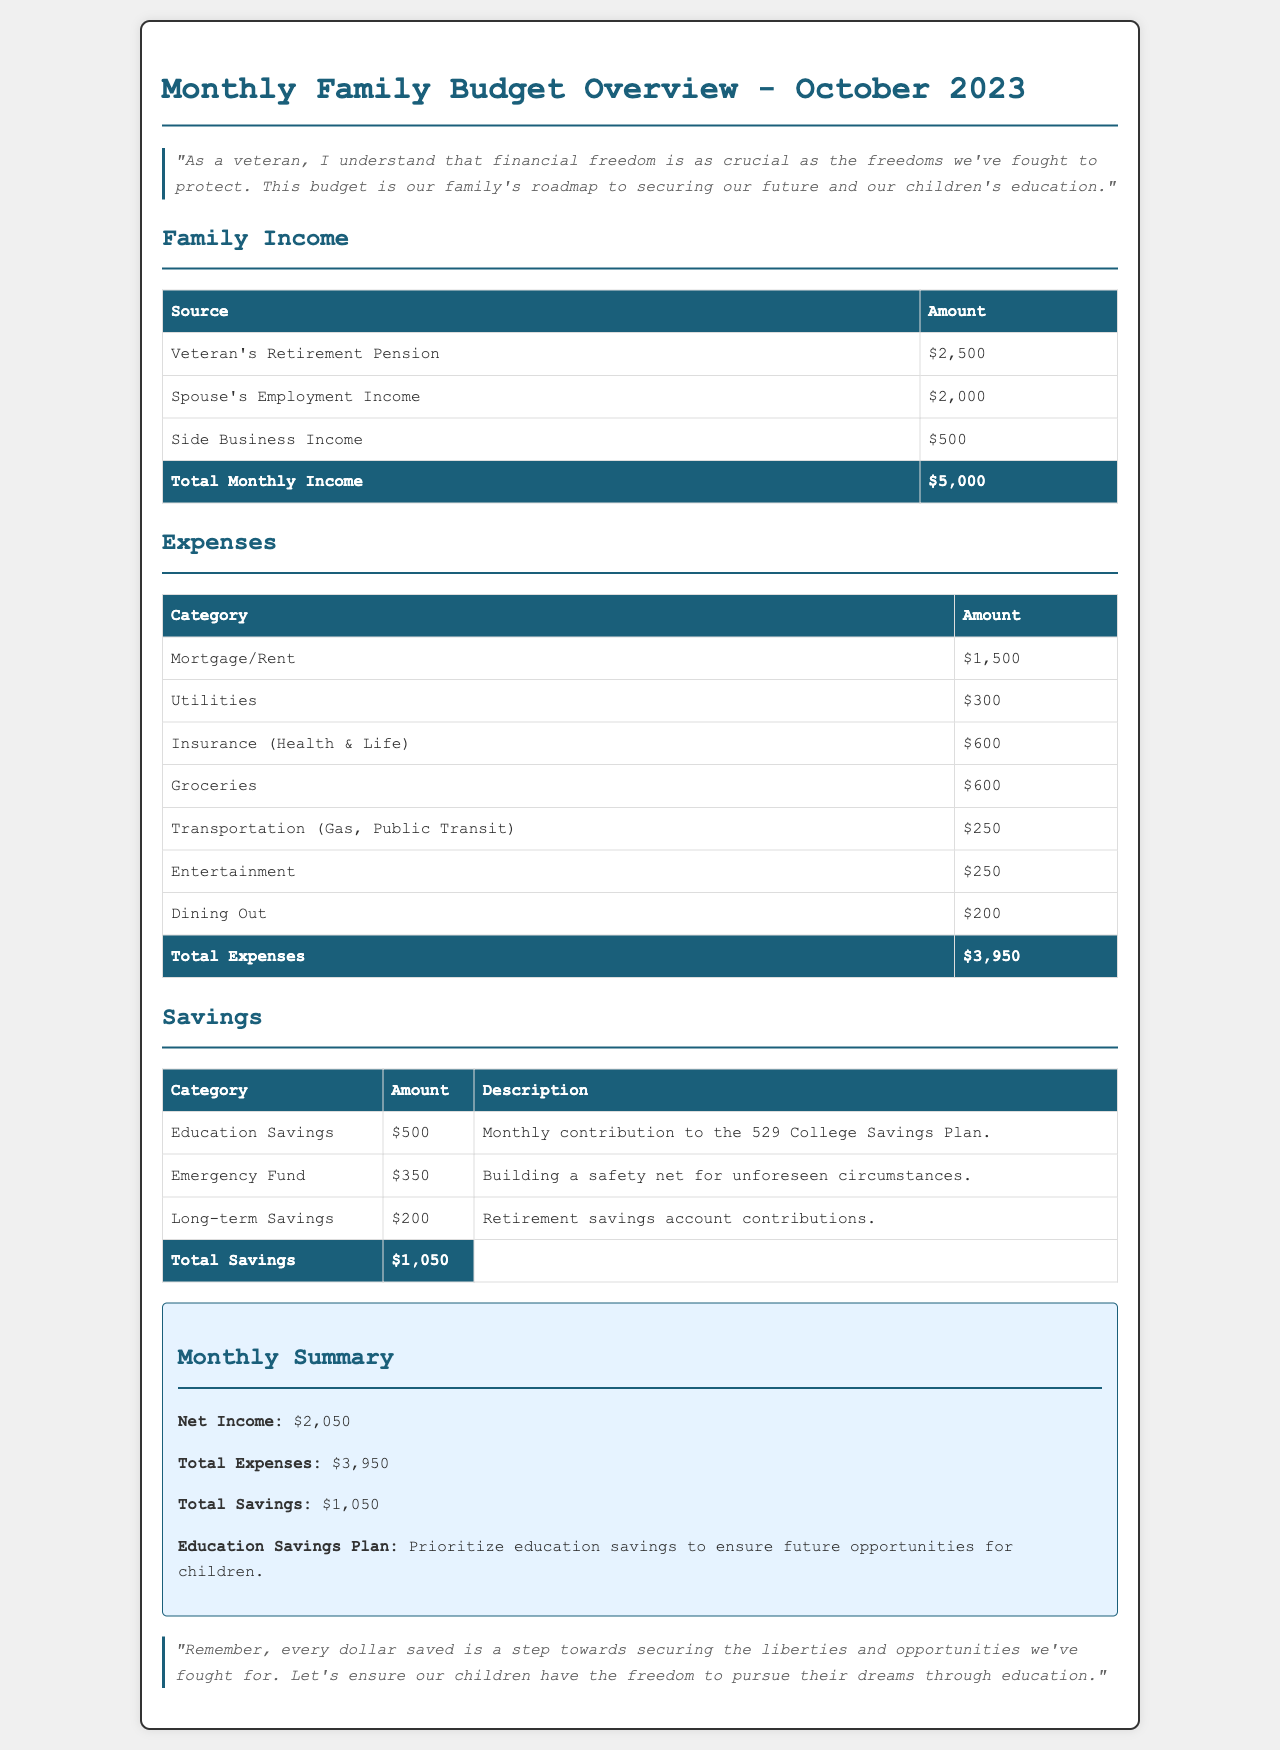What is the total monthly income? The total monthly income is the sum of all income sources listed in the document: $2,500 + $2,000 + $500 = $5,000.
Answer: $5,000 What is the category with the highest expense? The highest individual expense is the Mortgage/Rent at $1,500.
Answer: Mortgage/Rent How much is allocated for education savings? The document specifies a monthly contribution of $500 for Education Savings.
Answer: $500 What is the net income for the month? Net income is calculated by subtracting total expenses from total income: $5,000 - $3,950 = $2,050.
Answer: $2,050 What is the total amount spent on utilities? The total expense under the Utilities category is stated in the document as $300.
Answer: $300 How much is saved in the Emergency Fund? The Emergency Fund savings amount is detailed as $350 in the document.
Answer: $350 What percentage of total income is saved? Total savings is $1,050 out of total income $5,000 which is 21%.
Answer: 21% What is the total amount spent on dining out? The document lists the total spent on Dining Out as $200.
Answer: $200 What type of accounts are included in long-term savings? Long-term savings includes contributions to retirement savings accounts.
Answer: Retirement savings accounts 